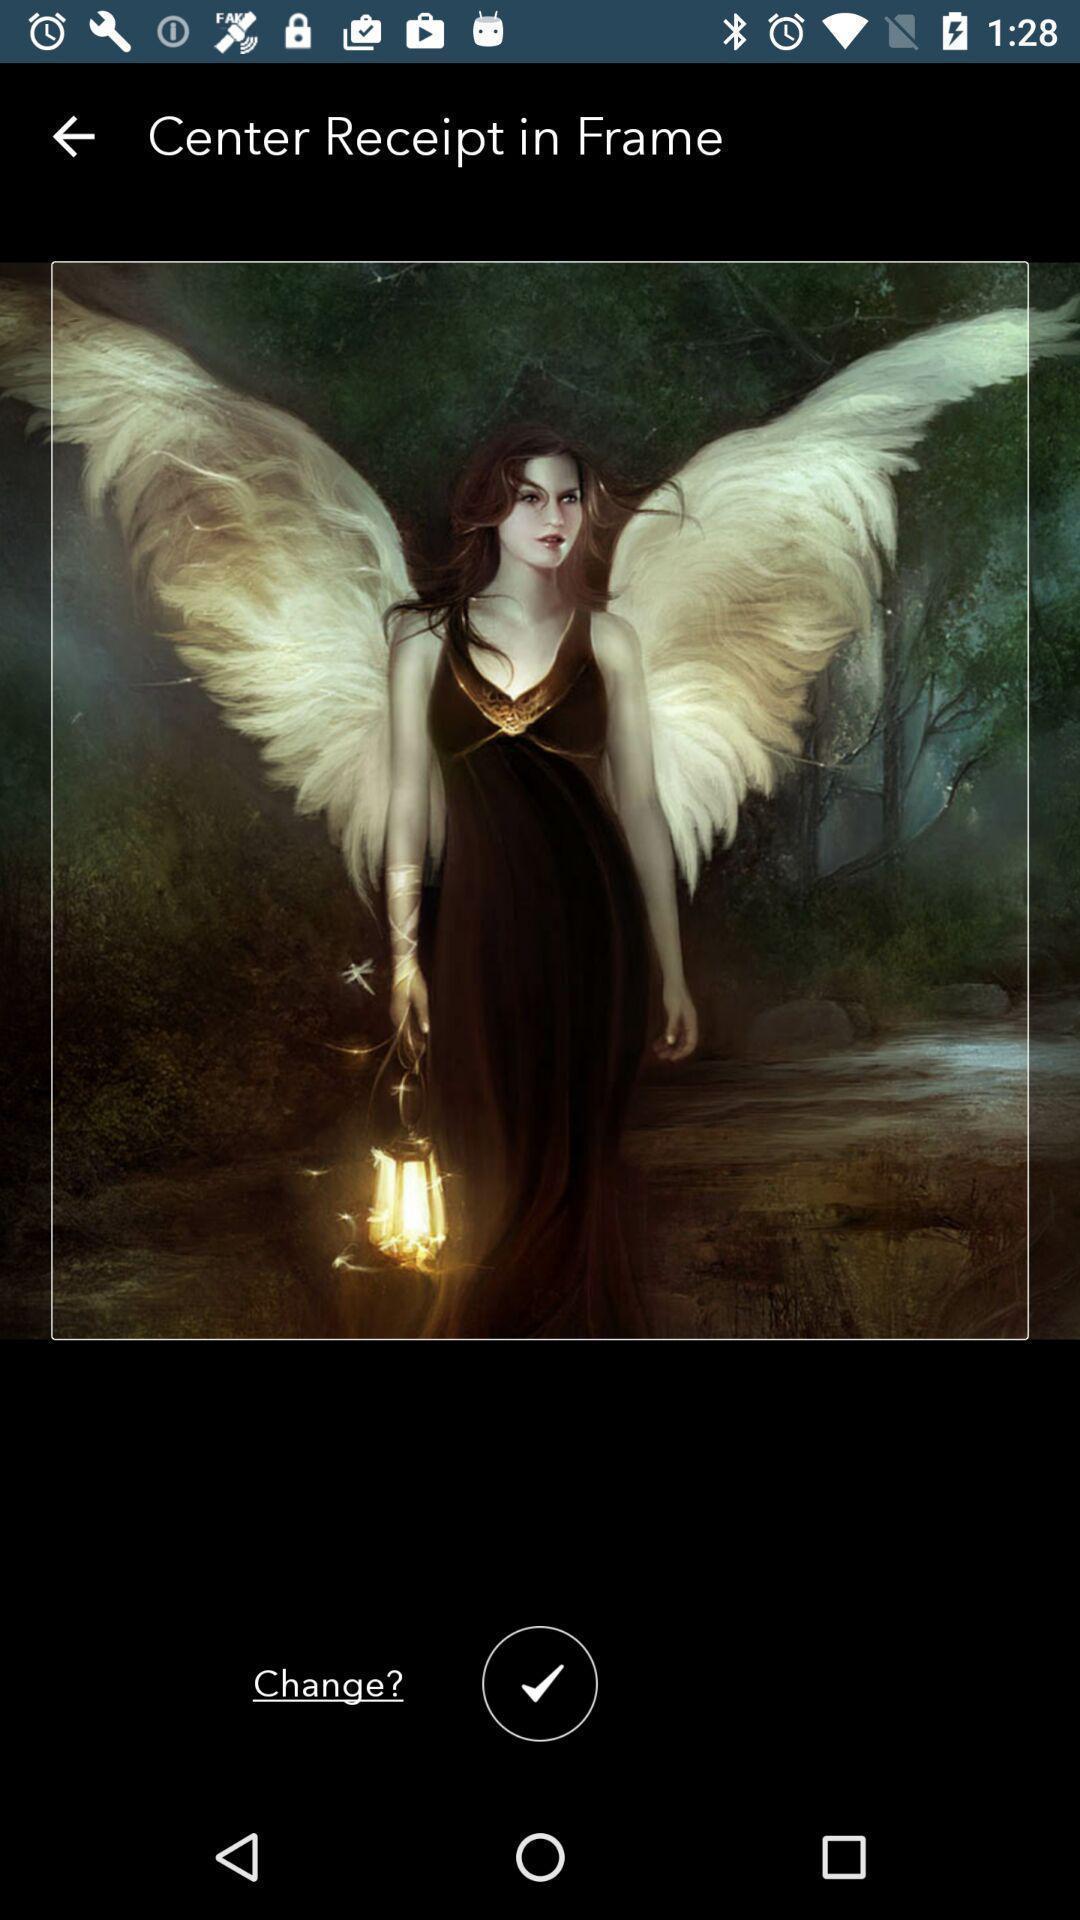Please provide a description for this image. Screen displaying about painting in app. 